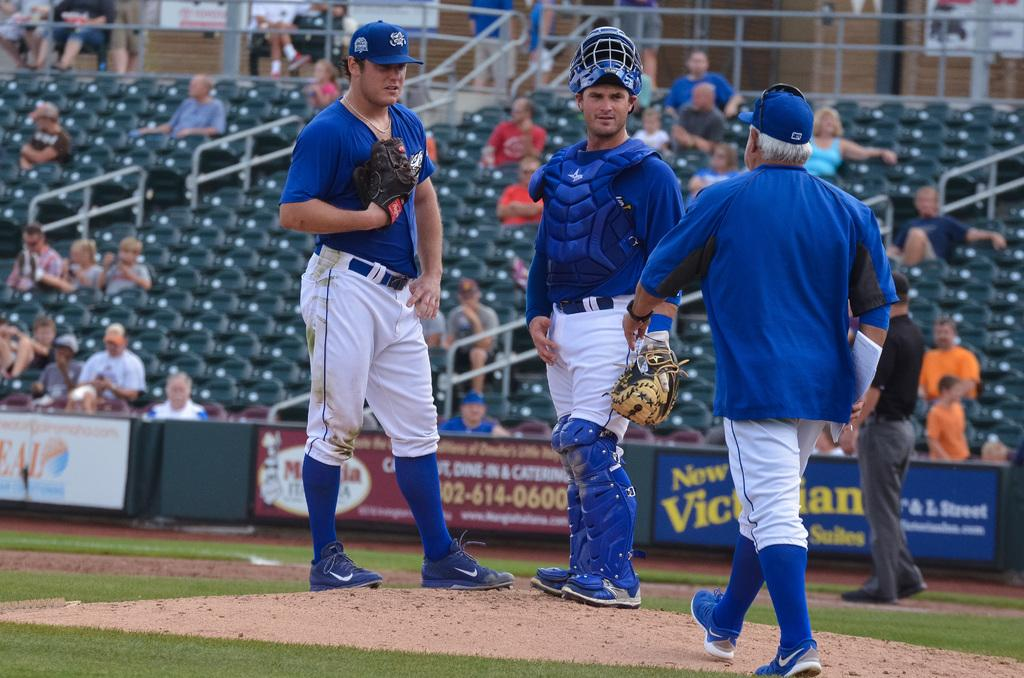<image>
Render a clear and concise summary of the photo. A phone number on a ballpark advertisement includes 614-0600. 